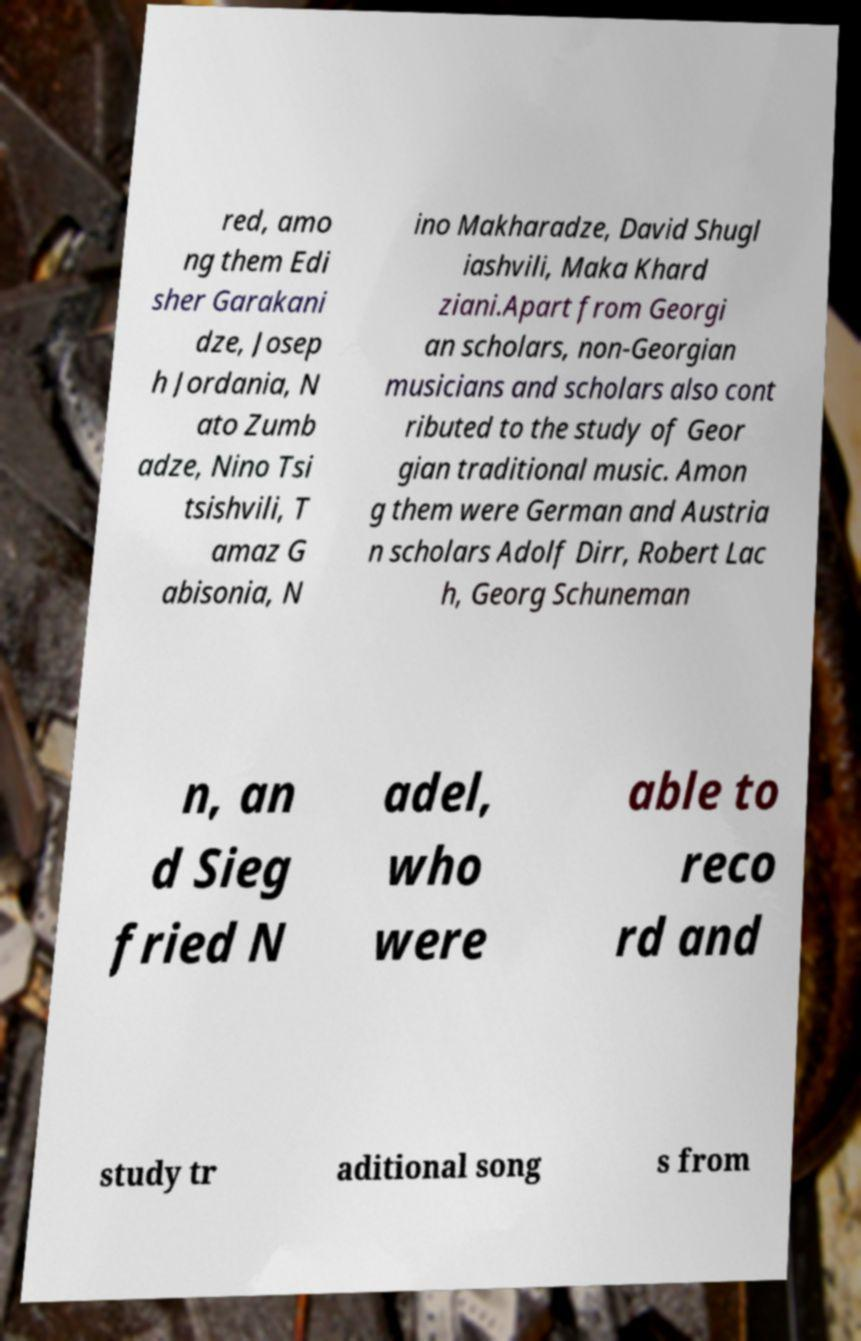Can you accurately transcribe the text from the provided image for me? red, amo ng them Edi sher Garakani dze, Josep h Jordania, N ato Zumb adze, Nino Tsi tsishvili, T amaz G abisonia, N ino Makharadze, David Shugl iashvili, Maka Khard ziani.Apart from Georgi an scholars, non-Georgian musicians and scholars also cont ributed to the study of Geor gian traditional music. Amon g them were German and Austria n scholars Adolf Dirr, Robert Lac h, Georg Schuneman n, an d Sieg fried N adel, who were able to reco rd and study tr aditional song s from 